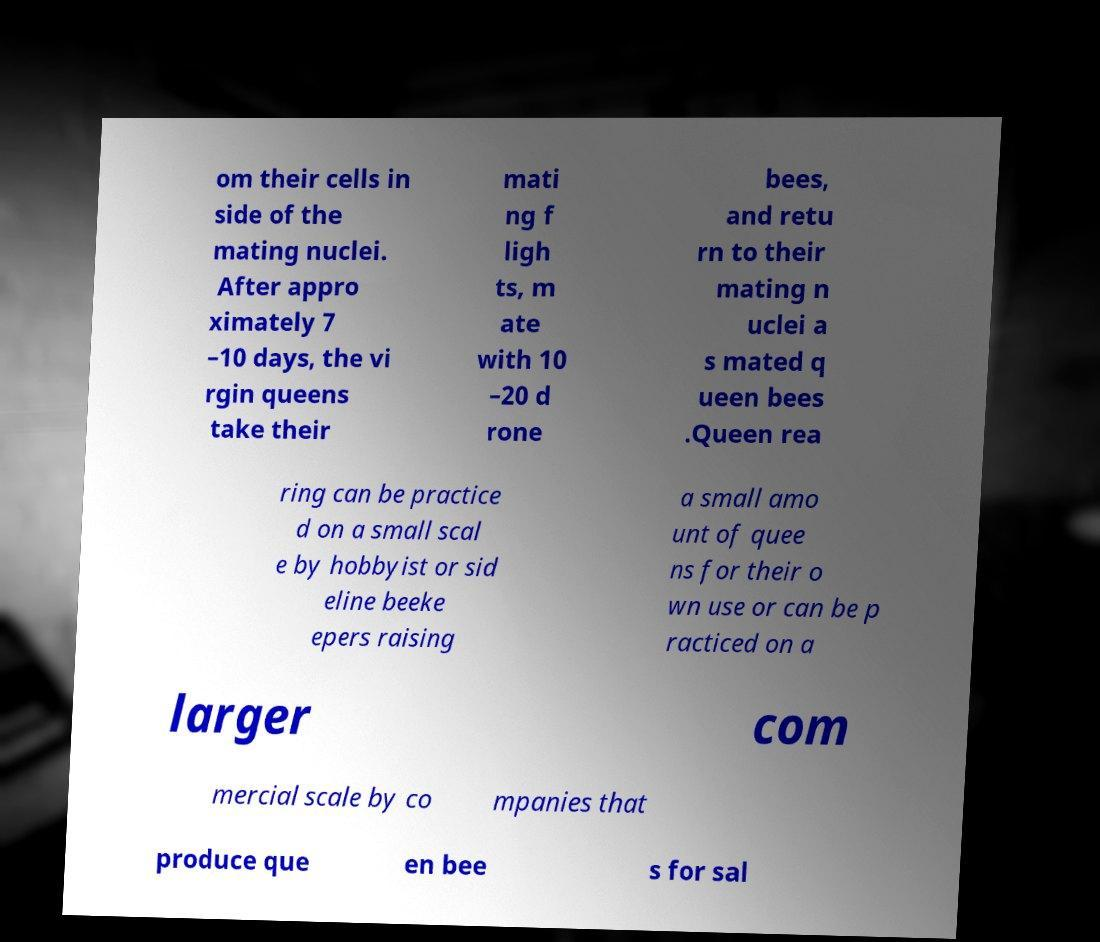What messages or text are displayed in this image? I need them in a readable, typed format. om their cells in side of the mating nuclei. After appro ximately 7 –10 days, the vi rgin queens take their mati ng f ligh ts, m ate with 10 –20 d rone bees, and retu rn to their mating n uclei a s mated q ueen bees .Queen rea ring can be practice d on a small scal e by hobbyist or sid eline beeke epers raising a small amo unt of quee ns for their o wn use or can be p racticed on a larger com mercial scale by co mpanies that produce que en bee s for sal 